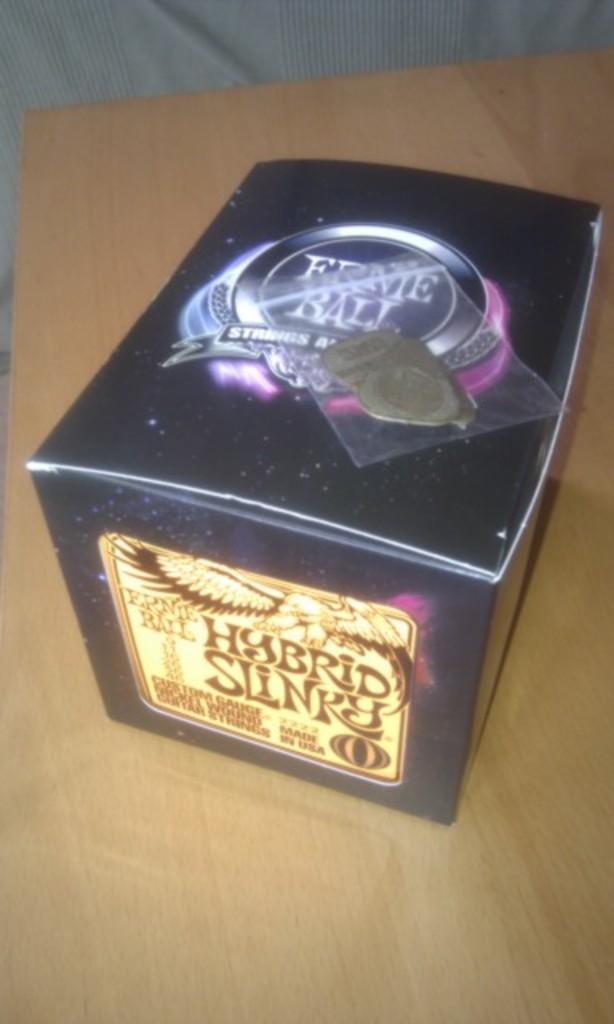What kind of slinky is it?
Provide a succinct answer. Hybrid. What kind of item is in the box?
Offer a terse response. Hybrid slinky. 